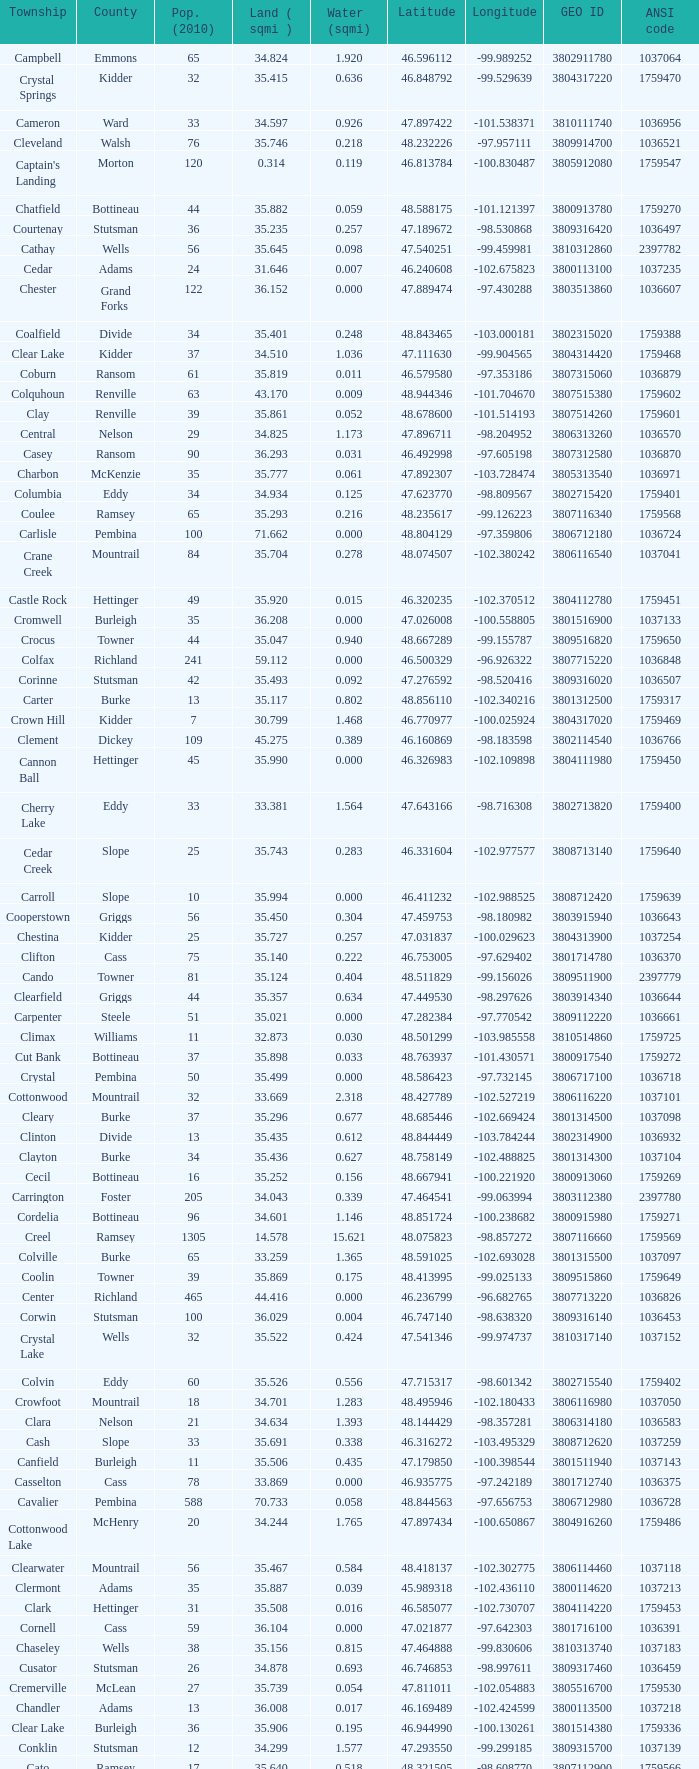What was the longitude of the township with a latitude of 48.075823? -98.857272. 